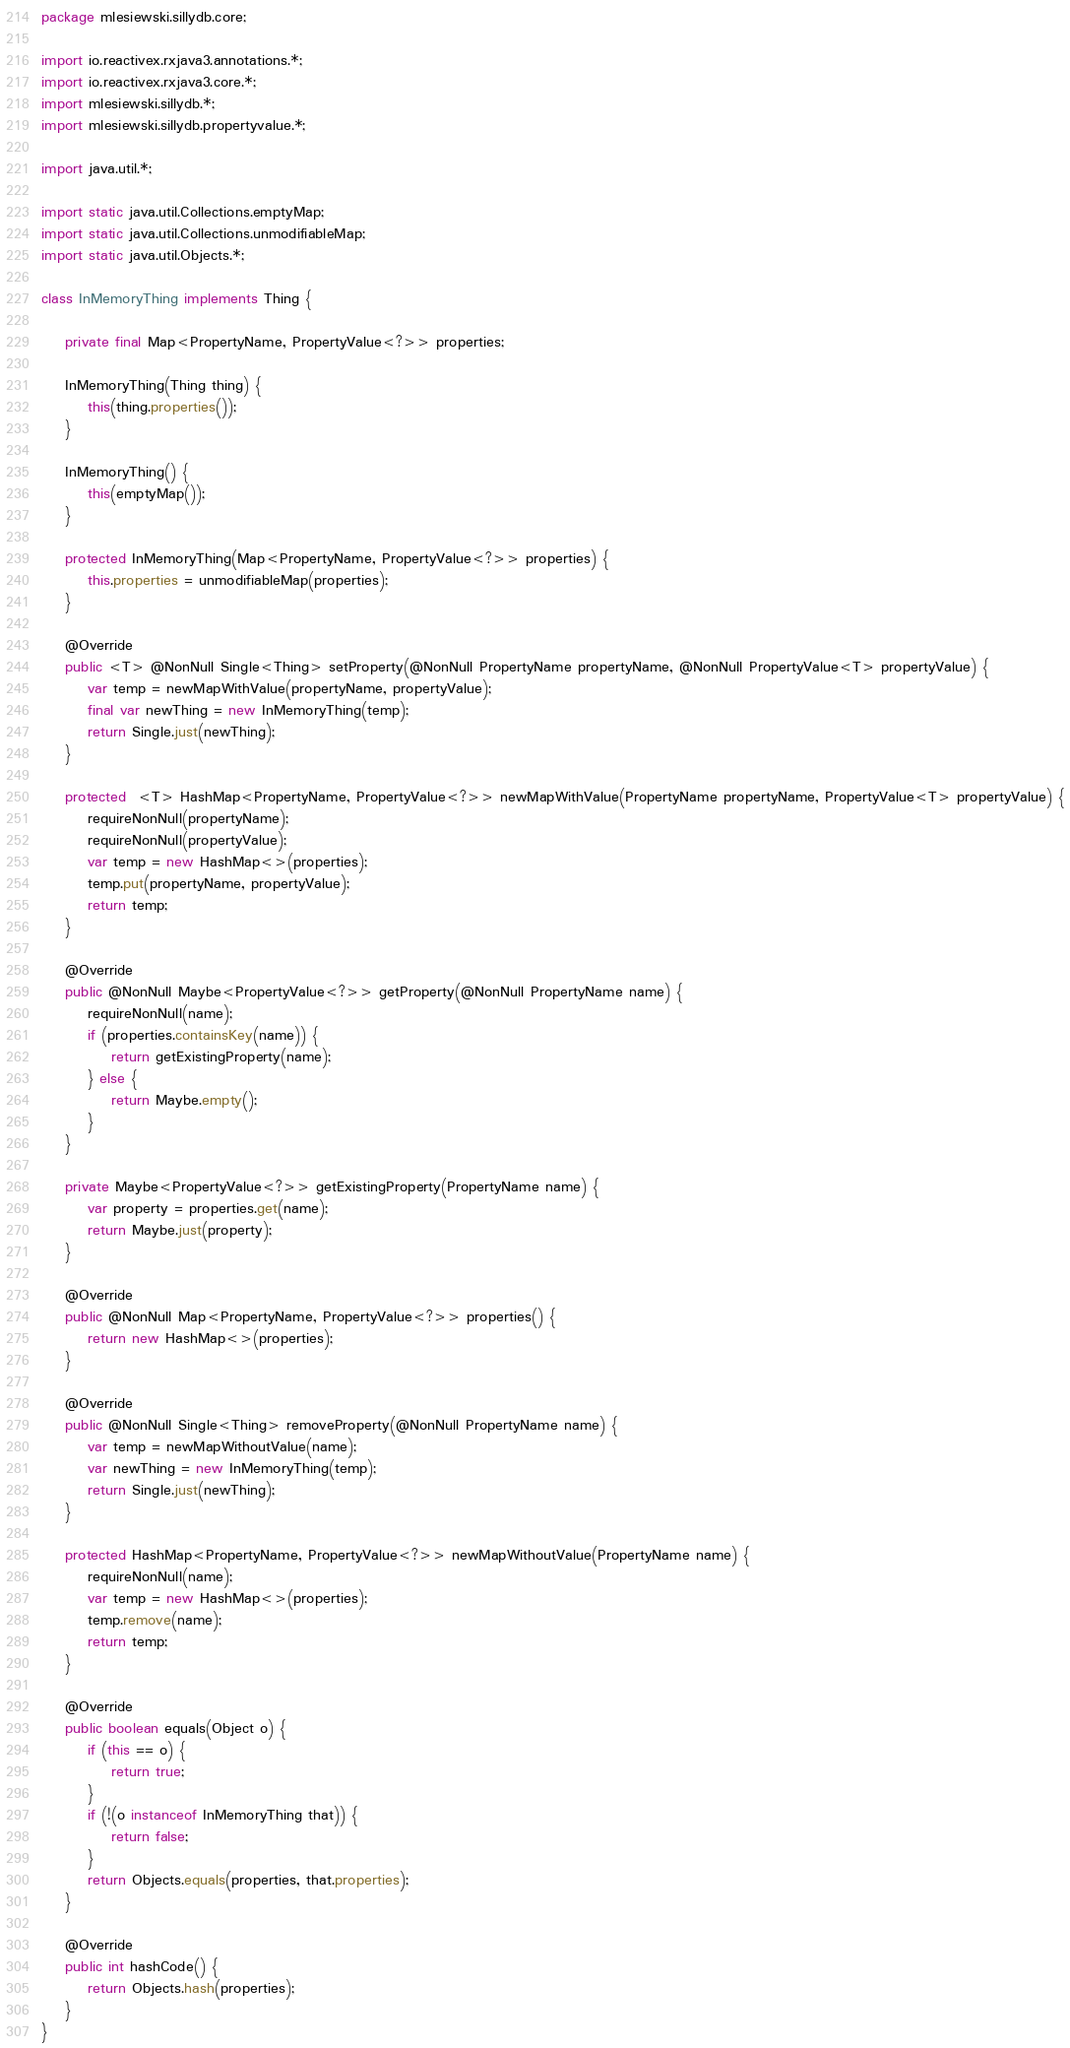Convert code to text. <code><loc_0><loc_0><loc_500><loc_500><_Java_>package mlesiewski.sillydb.core;

import io.reactivex.rxjava3.annotations.*;
import io.reactivex.rxjava3.core.*;
import mlesiewski.sillydb.*;
import mlesiewski.sillydb.propertyvalue.*;

import java.util.*;

import static java.util.Collections.emptyMap;
import static java.util.Collections.unmodifiableMap;
import static java.util.Objects.*;

class InMemoryThing implements Thing {

    private final Map<PropertyName, PropertyValue<?>> properties;

    InMemoryThing(Thing thing) {
        this(thing.properties());
    }

    InMemoryThing() {
        this(emptyMap());
    }

    protected InMemoryThing(Map<PropertyName, PropertyValue<?>> properties) {
        this.properties = unmodifiableMap(properties);
    }

    @Override
    public <T> @NonNull Single<Thing> setProperty(@NonNull PropertyName propertyName, @NonNull PropertyValue<T> propertyValue) {
        var temp = newMapWithValue(propertyName, propertyValue);
        final var newThing = new InMemoryThing(temp);
        return Single.just(newThing);
    }

    protected  <T> HashMap<PropertyName, PropertyValue<?>> newMapWithValue(PropertyName propertyName, PropertyValue<T> propertyValue) {
        requireNonNull(propertyName);
        requireNonNull(propertyValue);
        var temp = new HashMap<>(properties);
        temp.put(propertyName, propertyValue);
        return temp;
    }

    @Override
    public @NonNull Maybe<PropertyValue<?>> getProperty(@NonNull PropertyName name) {
        requireNonNull(name);
        if (properties.containsKey(name)) {
            return getExistingProperty(name);
        } else {
            return Maybe.empty();
        }
    }

    private Maybe<PropertyValue<?>> getExistingProperty(PropertyName name) {
        var property = properties.get(name);
        return Maybe.just(property);
    }

    @Override
    public @NonNull Map<PropertyName, PropertyValue<?>> properties() {
        return new HashMap<>(properties);
    }

    @Override
    public @NonNull Single<Thing> removeProperty(@NonNull PropertyName name) {
        var temp = newMapWithoutValue(name);
        var newThing = new InMemoryThing(temp);
        return Single.just(newThing);
    }

    protected HashMap<PropertyName, PropertyValue<?>> newMapWithoutValue(PropertyName name) {
        requireNonNull(name);
        var temp = new HashMap<>(properties);
        temp.remove(name);
        return temp;
    }

    @Override
    public boolean equals(Object o) {
        if (this == o) {
            return true;
        }
        if (!(o instanceof InMemoryThing that)) {
            return false;
        }
        return Objects.equals(properties, that.properties);
    }

    @Override
    public int hashCode() {
        return Objects.hash(properties);
    }
}
</code> 